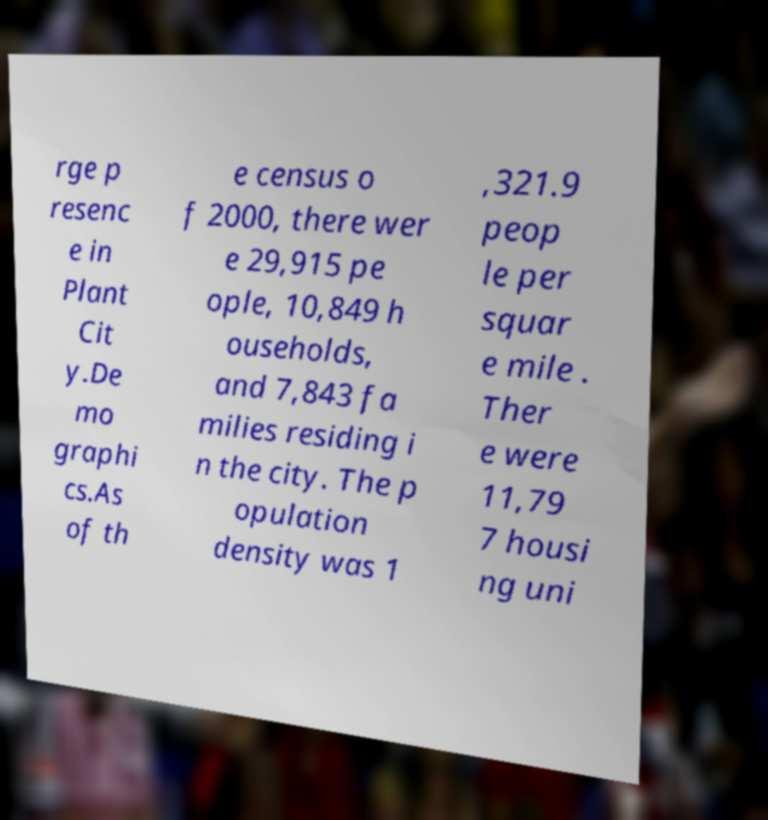Please read and relay the text visible in this image. What does it say? rge p resenc e in Plant Cit y.De mo graphi cs.As of th e census o f 2000, there wer e 29,915 pe ople, 10,849 h ouseholds, and 7,843 fa milies residing i n the city. The p opulation density was 1 ,321.9 peop le per squar e mile . Ther e were 11,79 7 housi ng uni 